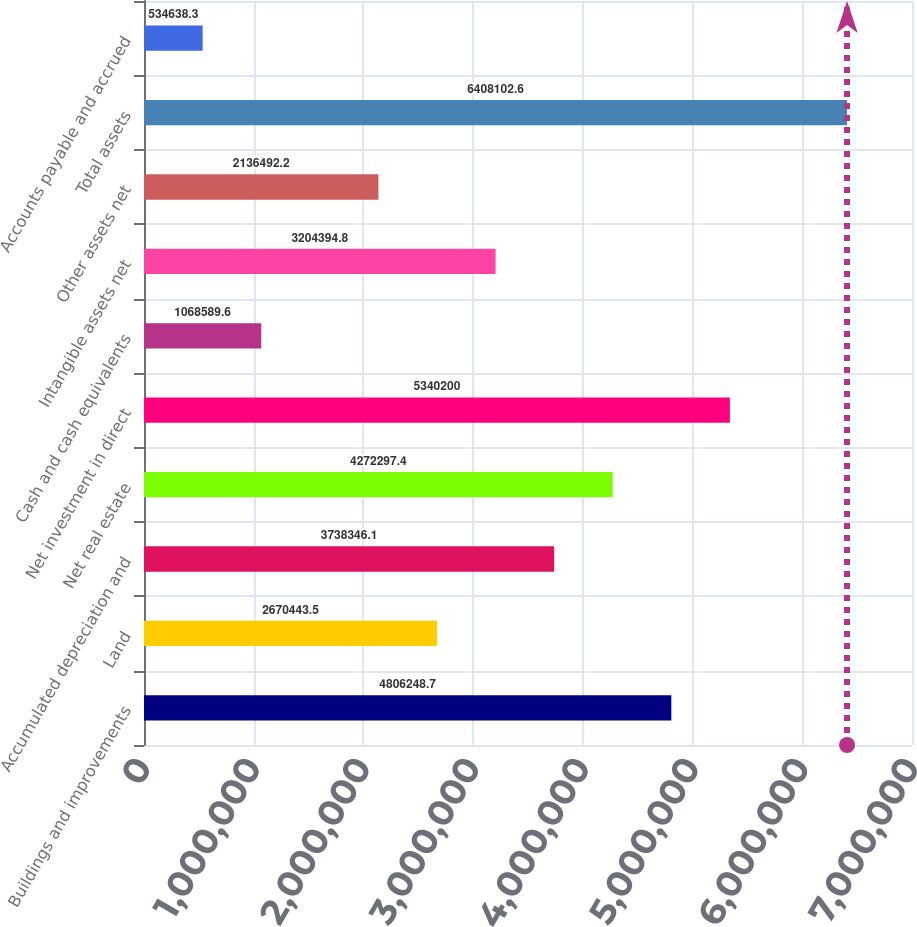Convert chart. <chart><loc_0><loc_0><loc_500><loc_500><bar_chart><fcel>Buildings and improvements<fcel>Land<fcel>Accumulated depreciation and<fcel>Net real estate<fcel>Net investment in direct<fcel>Cash and cash equivalents<fcel>Intangible assets net<fcel>Other assets net<fcel>Total assets<fcel>Accounts payable and accrued<nl><fcel>4.80625e+06<fcel>2.67044e+06<fcel>3.73835e+06<fcel>4.2723e+06<fcel>5.3402e+06<fcel>1.06859e+06<fcel>3.20439e+06<fcel>2.13649e+06<fcel>6.4081e+06<fcel>534638<nl></chart> 